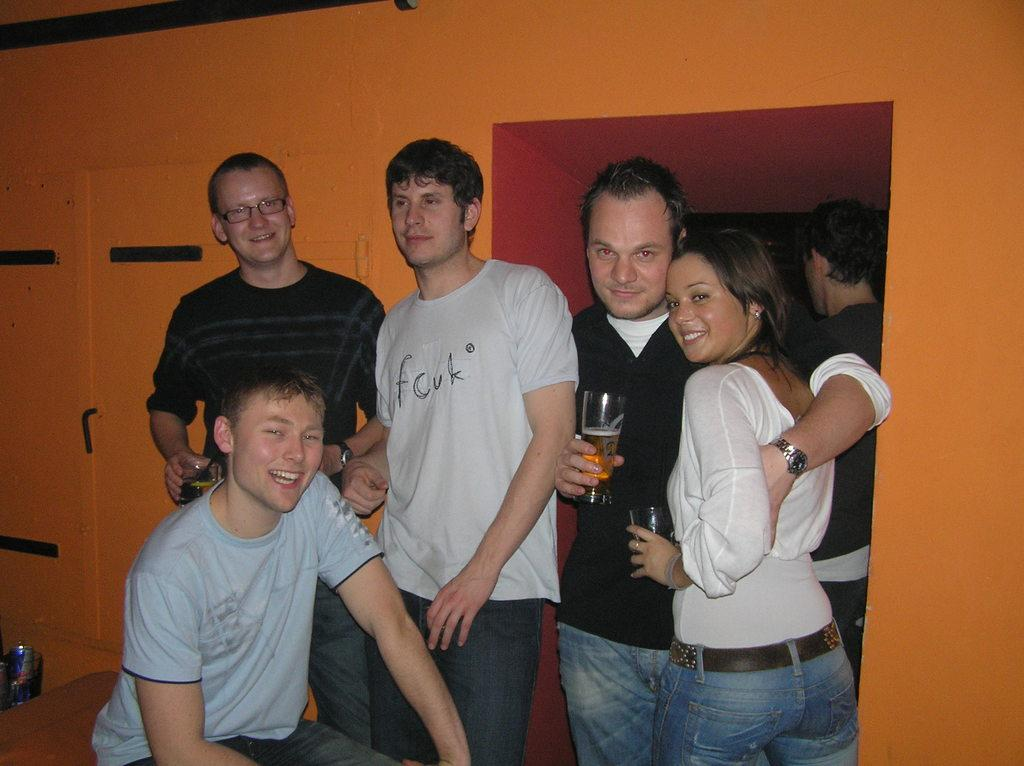What are the people in the image doing? The people in the image are standing and holding wine glasses. Can you describe the man's position in the image? There is a man sitting at the bottom of the image. What can be seen in the background of the image? There is a wall and a door in the background of the image. What type of amusement can be seen in the image? There is no amusement present in the image; it features people standing and holding wine glasses, a sitting man, and a wall with a door in the background. What kind of lunch is being served in the image? There is no lunch being served in the image; it only shows people holding wine glasses and a sitting man. 